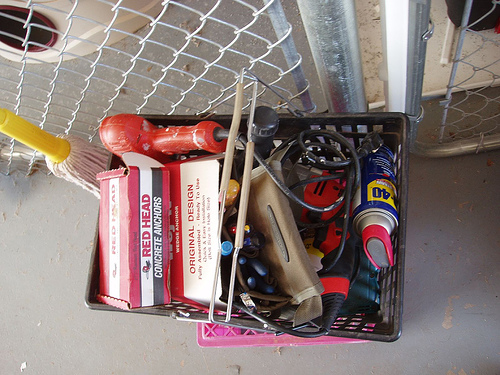<image>
Is there a drill behind the concrete anchors? Yes. From this viewpoint, the drill is positioned behind the concrete anchors, with the concrete anchors partially or fully occluding the drill. Is the oil can in the floor? No. The oil can is not contained within the floor. These objects have a different spatial relationship. Where is the mop in relation to the concrete? Is it above the concrete? Yes. The mop is positioned above the concrete in the vertical space, higher up in the scene. 